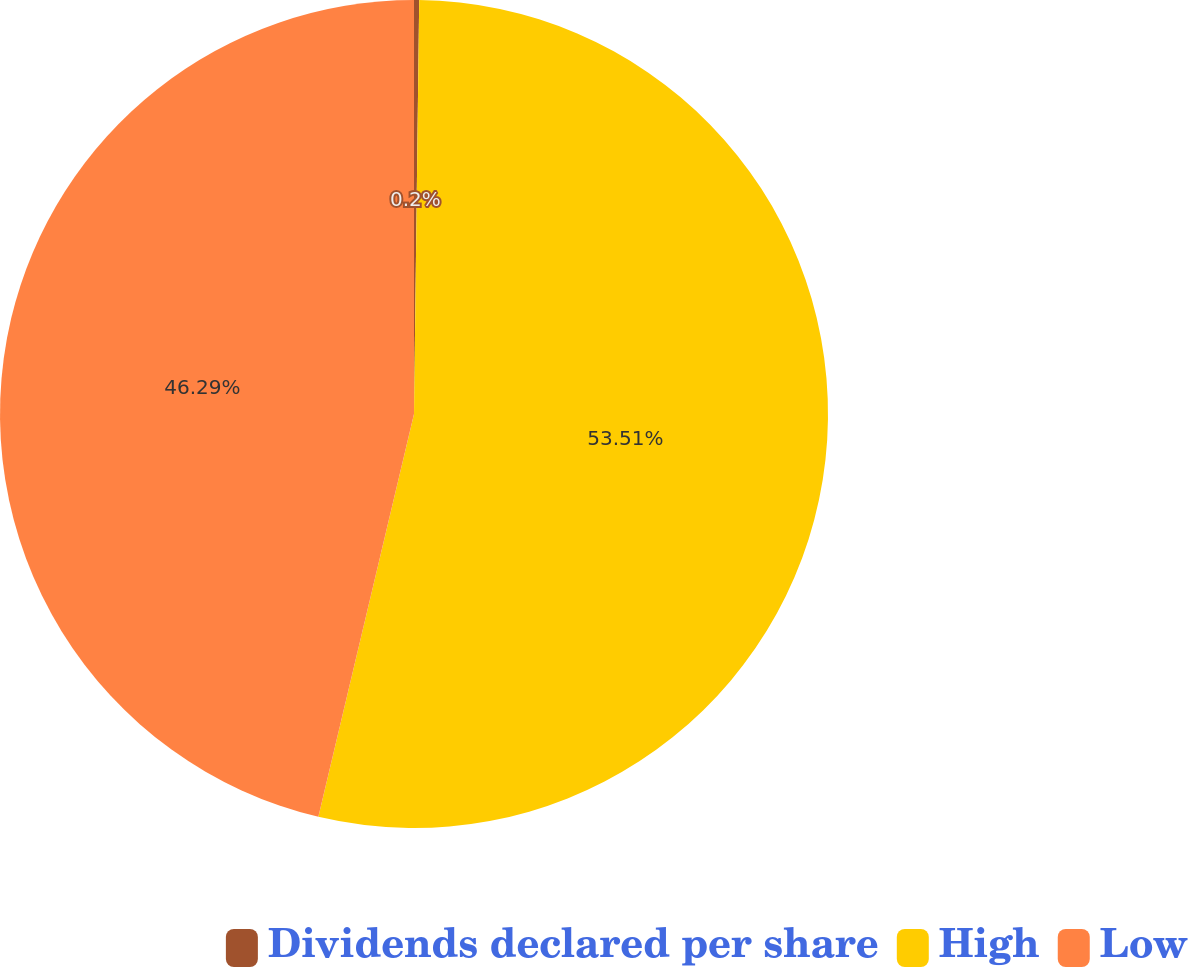<chart> <loc_0><loc_0><loc_500><loc_500><pie_chart><fcel>Dividends declared per share<fcel>High<fcel>Low<nl><fcel>0.2%<fcel>53.51%<fcel>46.29%<nl></chart> 